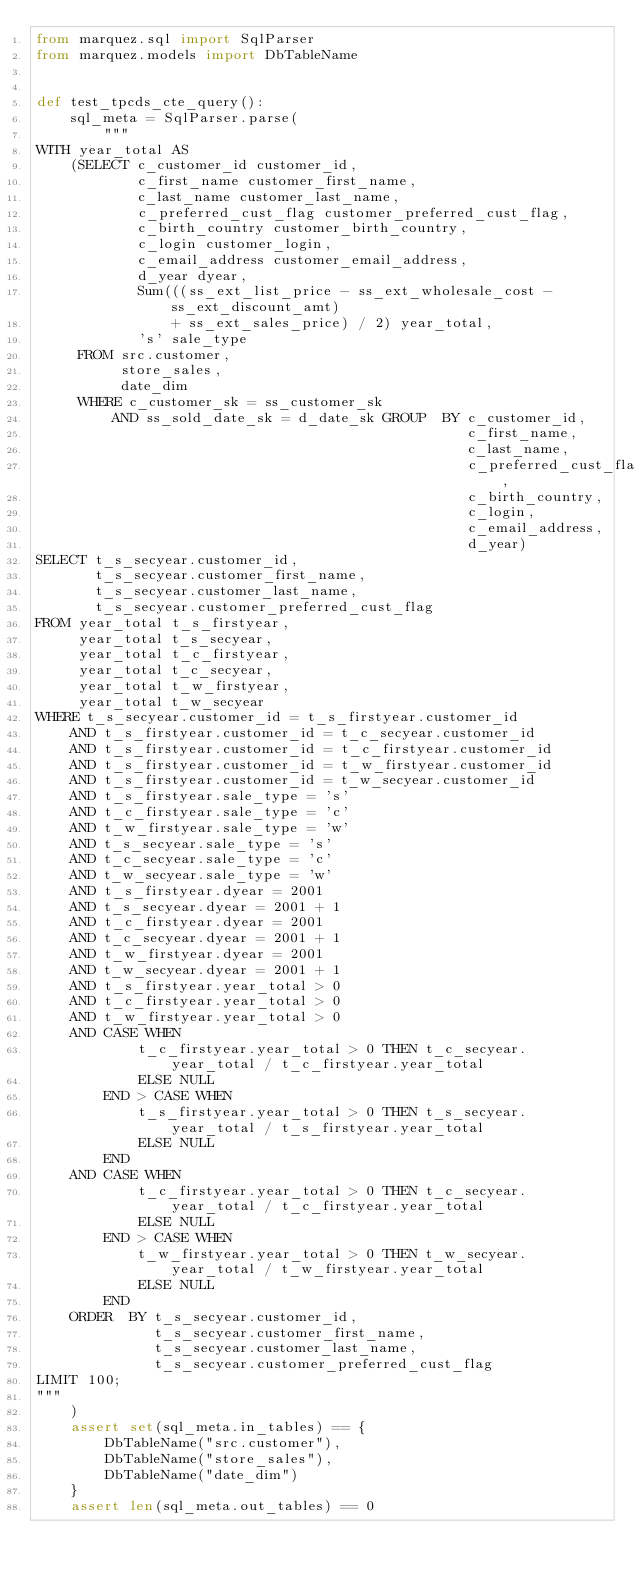Convert code to text. <code><loc_0><loc_0><loc_500><loc_500><_Python_>from marquez.sql import SqlParser
from marquez.models import DbTableName


def test_tpcds_cte_query():
    sql_meta = SqlParser.parse(
        """
WITH year_total AS
    (SELECT c_customer_id customer_id,
            c_first_name customer_first_name,
            c_last_name customer_last_name,
            c_preferred_cust_flag customer_preferred_cust_flag,
            c_birth_country customer_birth_country,
            c_login customer_login,
            c_email_address customer_email_address,
            d_year dyear,
            Sum(((ss_ext_list_price - ss_ext_wholesale_cost - ss_ext_discount_amt)
                + ss_ext_sales_price) / 2) year_total,
            's' sale_type
     FROM src.customer,
          store_sales,
          date_dim
     WHERE c_customer_sk = ss_customer_sk
         AND ss_sold_date_sk = d_date_sk GROUP  BY c_customer_id,
                                                   c_first_name,
                                                   c_last_name,
                                                   c_preferred_cust_flag,
                                                   c_birth_country,
                                                   c_login,
                                                   c_email_address,
                                                   d_year)
SELECT t_s_secyear.customer_id,
       t_s_secyear.customer_first_name,
       t_s_secyear.customer_last_name,
       t_s_secyear.customer_preferred_cust_flag
FROM year_total t_s_firstyear,
     year_total t_s_secyear,
     year_total t_c_firstyear,
     year_total t_c_secyear,
     year_total t_w_firstyear,
     year_total t_w_secyear
WHERE t_s_secyear.customer_id = t_s_firstyear.customer_id
    AND t_s_firstyear.customer_id = t_c_secyear.customer_id
    AND t_s_firstyear.customer_id = t_c_firstyear.customer_id
    AND t_s_firstyear.customer_id = t_w_firstyear.customer_id
    AND t_s_firstyear.customer_id = t_w_secyear.customer_id
    AND t_s_firstyear.sale_type = 's'
    AND t_c_firstyear.sale_type = 'c'
    AND t_w_firstyear.sale_type = 'w'
    AND t_s_secyear.sale_type = 's'
    AND t_c_secyear.sale_type = 'c'
    AND t_w_secyear.sale_type = 'w'
    AND t_s_firstyear.dyear = 2001
    AND t_s_secyear.dyear = 2001 + 1
    AND t_c_firstyear.dyear = 2001
    AND t_c_secyear.dyear = 2001 + 1
    AND t_w_firstyear.dyear = 2001
    AND t_w_secyear.dyear = 2001 + 1
    AND t_s_firstyear.year_total > 0
    AND t_c_firstyear.year_total > 0
    AND t_w_firstyear.year_total > 0
    AND CASE WHEN
            t_c_firstyear.year_total > 0 THEN t_c_secyear.year_total / t_c_firstyear.year_total
            ELSE NULL
        END > CASE WHEN
            t_s_firstyear.year_total > 0 THEN t_s_secyear.year_total / t_s_firstyear.year_total
            ELSE NULL
        END
    AND CASE WHEN
            t_c_firstyear.year_total > 0 THEN t_c_secyear.year_total / t_c_firstyear.year_total
            ELSE NULL
        END > CASE WHEN
            t_w_firstyear.year_total > 0 THEN t_w_secyear.year_total / t_w_firstyear.year_total
            ELSE NULL
        END
    ORDER  BY t_s_secyear.customer_id,
              t_s_secyear.customer_first_name,
              t_s_secyear.customer_last_name,
              t_s_secyear.customer_preferred_cust_flag
LIMIT 100;
"""
    )
    assert set(sql_meta.in_tables) == {
        DbTableName("src.customer"),
        DbTableName("store_sales"),
        DbTableName("date_dim")
    }
    assert len(sql_meta.out_tables) == 0
</code> 